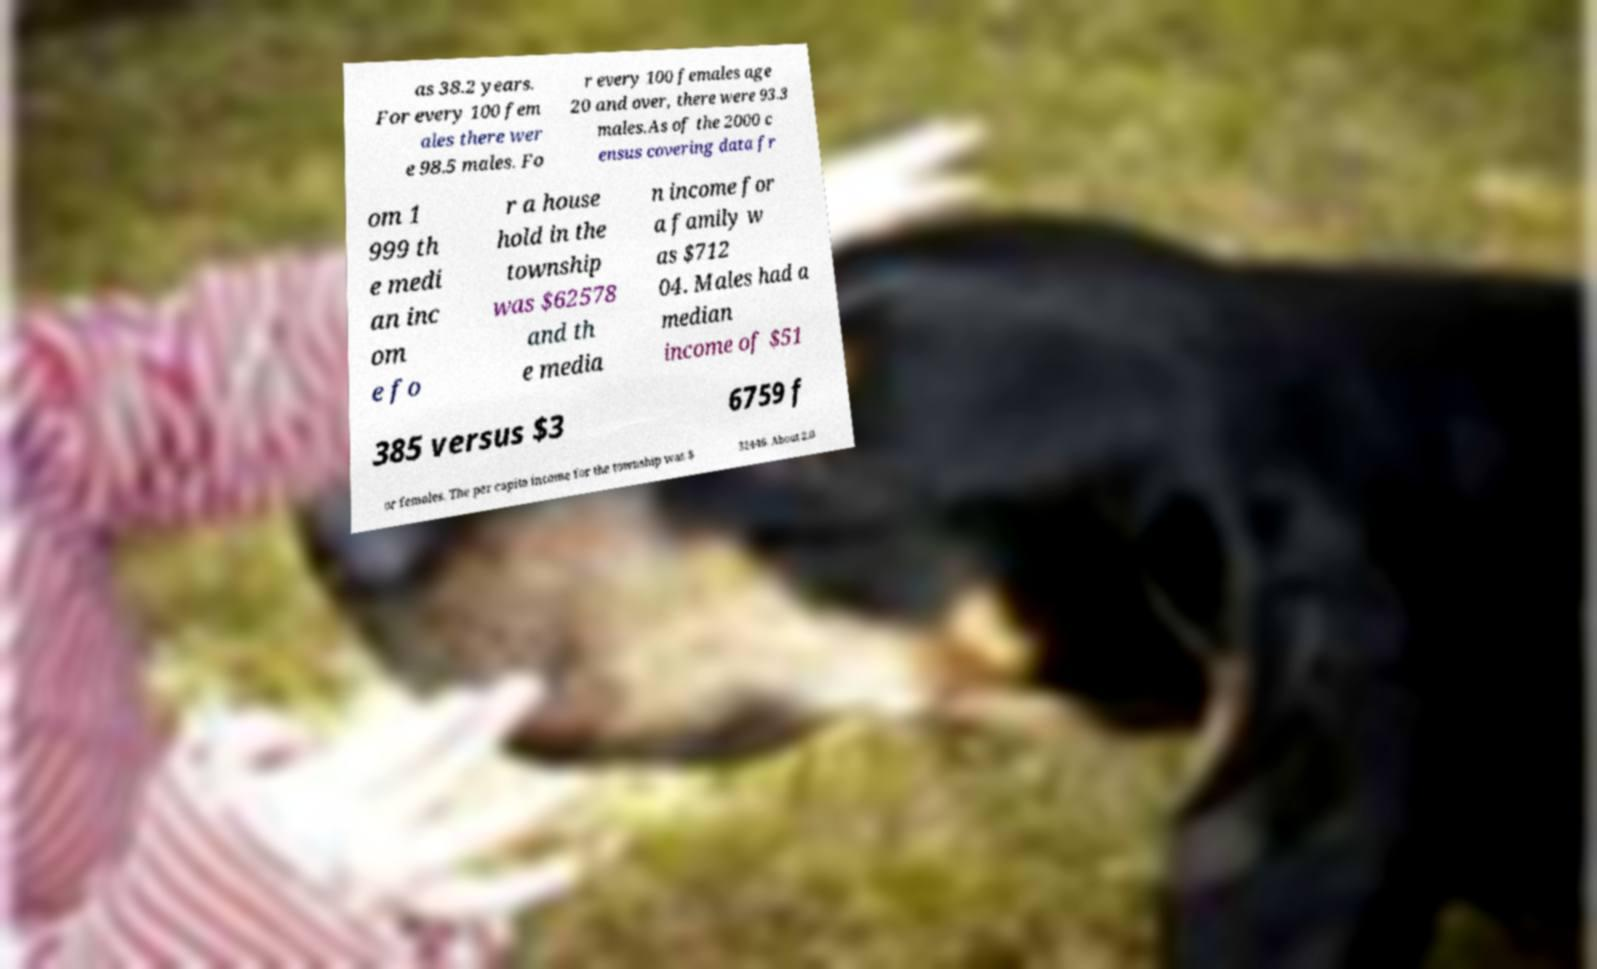Can you accurately transcribe the text from the provided image for me? as 38.2 years. For every 100 fem ales there wer e 98.5 males. Fo r every 100 females age 20 and over, there were 93.3 males.As of the 2000 c ensus covering data fr om 1 999 th e medi an inc om e fo r a house hold in the township was $62578 and th e media n income for a family w as $712 04. Males had a median income of $51 385 versus $3 6759 f or females. The per capita income for the township was $ 32446. About 2.0 